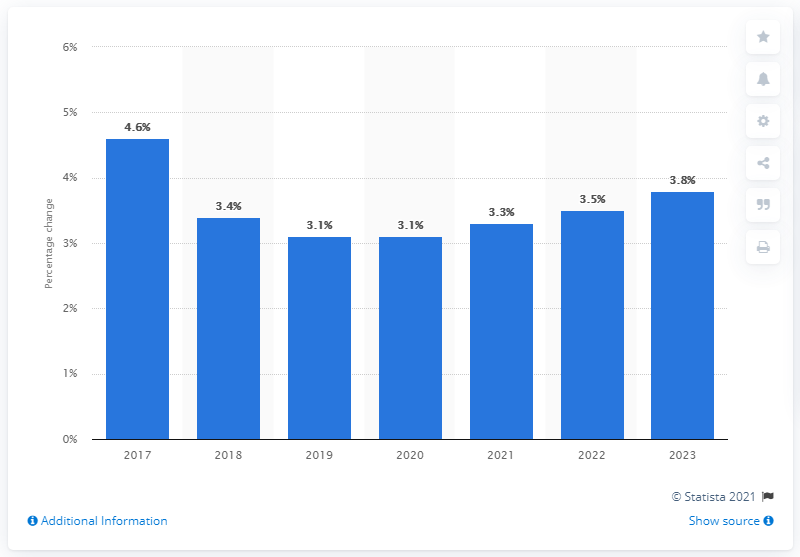Identify some key points in this picture. It is projected that the increase in house prices in 2023 will be 3.8%. 